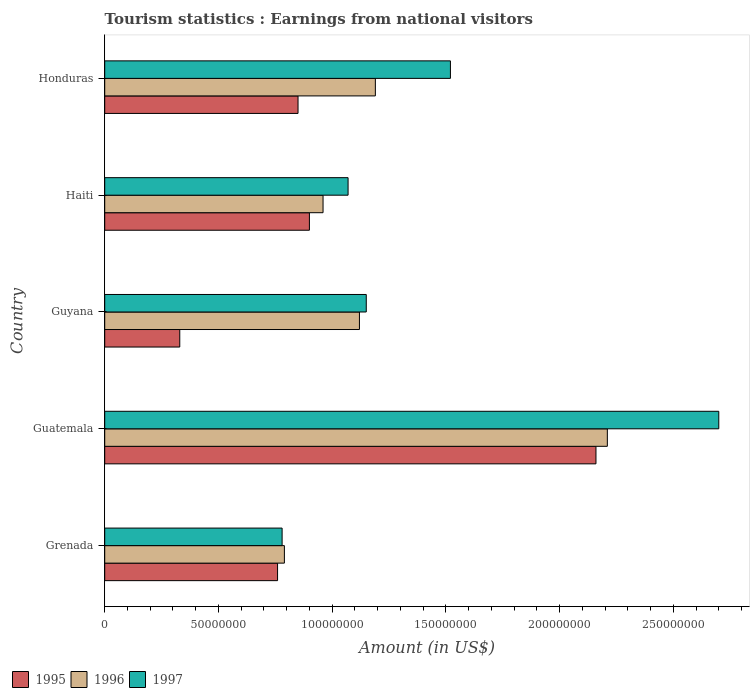How many different coloured bars are there?
Offer a very short reply. 3. How many groups of bars are there?
Provide a succinct answer. 5. Are the number of bars on each tick of the Y-axis equal?
Offer a very short reply. Yes. What is the label of the 4th group of bars from the top?
Keep it short and to the point. Guatemala. In how many cases, is the number of bars for a given country not equal to the number of legend labels?
Your answer should be very brief. 0. What is the earnings from national visitors in 1996 in Guatemala?
Give a very brief answer. 2.21e+08. Across all countries, what is the maximum earnings from national visitors in 1997?
Provide a succinct answer. 2.70e+08. Across all countries, what is the minimum earnings from national visitors in 1996?
Your answer should be compact. 7.90e+07. In which country was the earnings from national visitors in 1996 maximum?
Offer a terse response. Guatemala. In which country was the earnings from national visitors in 1997 minimum?
Your response must be concise. Grenada. What is the total earnings from national visitors in 1997 in the graph?
Keep it short and to the point. 7.22e+08. What is the difference between the earnings from national visitors in 1996 in Grenada and that in Guyana?
Keep it short and to the point. -3.30e+07. What is the difference between the earnings from national visitors in 1995 in Guyana and the earnings from national visitors in 1997 in Honduras?
Offer a terse response. -1.19e+08. What is the difference between the earnings from national visitors in 1995 and earnings from national visitors in 1997 in Honduras?
Provide a short and direct response. -6.70e+07. In how many countries, is the earnings from national visitors in 1995 greater than 180000000 US$?
Your answer should be very brief. 1. What is the ratio of the earnings from national visitors in 1996 in Guyana to that in Honduras?
Your response must be concise. 0.94. Is the earnings from national visitors in 1997 in Grenada less than that in Guatemala?
Give a very brief answer. Yes. What is the difference between the highest and the second highest earnings from national visitors in 1997?
Ensure brevity in your answer.  1.18e+08. What is the difference between the highest and the lowest earnings from national visitors in 1997?
Provide a short and direct response. 1.92e+08. In how many countries, is the earnings from national visitors in 1996 greater than the average earnings from national visitors in 1996 taken over all countries?
Keep it short and to the point. 1. Is the sum of the earnings from national visitors in 1997 in Grenada and Haiti greater than the maximum earnings from national visitors in 1996 across all countries?
Provide a short and direct response. No. What does the 3rd bar from the top in Honduras represents?
Offer a terse response. 1995. Is it the case that in every country, the sum of the earnings from national visitors in 1996 and earnings from national visitors in 1997 is greater than the earnings from national visitors in 1995?
Give a very brief answer. Yes. Are all the bars in the graph horizontal?
Provide a succinct answer. Yes. Are the values on the major ticks of X-axis written in scientific E-notation?
Keep it short and to the point. No. How are the legend labels stacked?
Your response must be concise. Horizontal. What is the title of the graph?
Offer a terse response. Tourism statistics : Earnings from national visitors. Does "1984" appear as one of the legend labels in the graph?
Provide a succinct answer. No. What is the label or title of the Y-axis?
Ensure brevity in your answer.  Country. What is the Amount (in US$) of 1995 in Grenada?
Keep it short and to the point. 7.60e+07. What is the Amount (in US$) in 1996 in Grenada?
Give a very brief answer. 7.90e+07. What is the Amount (in US$) in 1997 in Grenada?
Your answer should be compact. 7.80e+07. What is the Amount (in US$) in 1995 in Guatemala?
Keep it short and to the point. 2.16e+08. What is the Amount (in US$) of 1996 in Guatemala?
Your answer should be very brief. 2.21e+08. What is the Amount (in US$) of 1997 in Guatemala?
Provide a short and direct response. 2.70e+08. What is the Amount (in US$) of 1995 in Guyana?
Your answer should be very brief. 3.30e+07. What is the Amount (in US$) in 1996 in Guyana?
Offer a terse response. 1.12e+08. What is the Amount (in US$) of 1997 in Guyana?
Keep it short and to the point. 1.15e+08. What is the Amount (in US$) of 1995 in Haiti?
Give a very brief answer. 9.00e+07. What is the Amount (in US$) in 1996 in Haiti?
Provide a succinct answer. 9.60e+07. What is the Amount (in US$) in 1997 in Haiti?
Provide a succinct answer. 1.07e+08. What is the Amount (in US$) in 1995 in Honduras?
Your response must be concise. 8.50e+07. What is the Amount (in US$) in 1996 in Honduras?
Give a very brief answer. 1.19e+08. What is the Amount (in US$) in 1997 in Honduras?
Give a very brief answer. 1.52e+08. Across all countries, what is the maximum Amount (in US$) of 1995?
Your answer should be very brief. 2.16e+08. Across all countries, what is the maximum Amount (in US$) of 1996?
Ensure brevity in your answer.  2.21e+08. Across all countries, what is the maximum Amount (in US$) of 1997?
Your answer should be very brief. 2.70e+08. Across all countries, what is the minimum Amount (in US$) in 1995?
Your answer should be very brief. 3.30e+07. Across all countries, what is the minimum Amount (in US$) of 1996?
Provide a short and direct response. 7.90e+07. Across all countries, what is the minimum Amount (in US$) of 1997?
Keep it short and to the point. 7.80e+07. What is the total Amount (in US$) of 1996 in the graph?
Ensure brevity in your answer.  6.27e+08. What is the total Amount (in US$) of 1997 in the graph?
Make the answer very short. 7.22e+08. What is the difference between the Amount (in US$) of 1995 in Grenada and that in Guatemala?
Offer a terse response. -1.40e+08. What is the difference between the Amount (in US$) in 1996 in Grenada and that in Guatemala?
Keep it short and to the point. -1.42e+08. What is the difference between the Amount (in US$) of 1997 in Grenada and that in Guatemala?
Offer a terse response. -1.92e+08. What is the difference between the Amount (in US$) in 1995 in Grenada and that in Guyana?
Your response must be concise. 4.30e+07. What is the difference between the Amount (in US$) of 1996 in Grenada and that in Guyana?
Provide a short and direct response. -3.30e+07. What is the difference between the Amount (in US$) of 1997 in Grenada and that in Guyana?
Your answer should be compact. -3.70e+07. What is the difference between the Amount (in US$) of 1995 in Grenada and that in Haiti?
Provide a short and direct response. -1.40e+07. What is the difference between the Amount (in US$) in 1996 in Grenada and that in Haiti?
Your answer should be compact. -1.70e+07. What is the difference between the Amount (in US$) of 1997 in Grenada and that in Haiti?
Offer a terse response. -2.90e+07. What is the difference between the Amount (in US$) of 1995 in Grenada and that in Honduras?
Your response must be concise. -9.00e+06. What is the difference between the Amount (in US$) in 1996 in Grenada and that in Honduras?
Provide a succinct answer. -4.00e+07. What is the difference between the Amount (in US$) in 1997 in Grenada and that in Honduras?
Ensure brevity in your answer.  -7.40e+07. What is the difference between the Amount (in US$) of 1995 in Guatemala and that in Guyana?
Provide a succinct answer. 1.83e+08. What is the difference between the Amount (in US$) in 1996 in Guatemala and that in Guyana?
Make the answer very short. 1.09e+08. What is the difference between the Amount (in US$) of 1997 in Guatemala and that in Guyana?
Keep it short and to the point. 1.55e+08. What is the difference between the Amount (in US$) in 1995 in Guatemala and that in Haiti?
Offer a terse response. 1.26e+08. What is the difference between the Amount (in US$) of 1996 in Guatemala and that in Haiti?
Ensure brevity in your answer.  1.25e+08. What is the difference between the Amount (in US$) in 1997 in Guatemala and that in Haiti?
Keep it short and to the point. 1.63e+08. What is the difference between the Amount (in US$) of 1995 in Guatemala and that in Honduras?
Your answer should be very brief. 1.31e+08. What is the difference between the Amount (in US$) of 1996 in Guatemala and that in Honduras?
Make the answer very short. 1.02e+08. What is the difference between the Amount (in US$) of 1997 in Guatemala and that in Honduras?
Keep it short and to the point. 1.18e+08. What is the difference between the Amount (in US$) of 1995 in Guyana and that in Haiti?
Make the answer very short. -5.70e+07. What is the difference between the Amount (in US$) in 1996 in Guyana and that in Haiti?
Your response must be concise. 1.60e+07. What is the difference between the Amount (in US$) of 1995 in Guyana and that in Honduras?
Offer a terse response. -5.20e+07. What is the difference between the Amount (in US$) in 1996 in Guyana and that in Honduras?
Give a very brief answer. -7.00e+06. What is the difference between the Amount (in US$) of 1997 in Guyana and that in Honduras?
Your answer should be compact. -3.70e+07. What is the difference between the Amount (in US$) of 1995 in Haiti and that in Honduras?
Keep it short and to the point. 5.00e+06. What is the difference between the Amount (in US$) in 1996 in Haiti and that in Honduras?
Offer a terse response. -2.30e+07. What is the difference between the Amount (in US$) of 1997 in Haiti and that in Honduras?
Ensure brevity in your answer.  -4.50e+07. What is the difference between the Amount (in US$) of 1995 in Grenada and the Amount (in US$) of 1996 in Guatemala?
Make the answer very short. -1.45e+08. What is the difference between the Amount (in US$) in 1995 in Grenada and the Amount (in US$) in 1997 in Guatemala?
Offer a terse response. -1.94e+08. What is the difference between the Amount (in US$) of 1996 in Grenada and the Amount (in US$) of 1997 in Guatemala?
Your answer should be compact. -1.91e+08. What is the difference between the Amount (in US$) of 1995 in Grenada and the Amount (in US$) of 1996 in Guyana?
Offer a terse response. -3.60e+07. What is the difference between the Amount (in US$) in 1995 in Grenada and the Amount (in US$) in 1997 in Guyana?
Keep it short and to the point. -3.90e+07. What is the difference between the Amount (in US$) of 1996 in Grenada and the Amount (in US$) of 1997 in Guyana?
Offer a very short reply. -3.60e+07. What is the difference between the Amount (in US$) of 1995 in Grenada and the Amount (in US$) of 1996 in Haiti?
Offer a terse response. -2.00e+07. What is the difference between the Amount (in US$) in 1995 in Grenada and the Amount (in US$) in 1997 in Haiti?
Ensure brevity in your answer.  -3.10e+07. What is the difference between the Amount (in US$) of 1996 in Grenada and the Amount (in US$) of 1997 in Haiti?
Offer a terse response. -2.80e+07. What is the difference between the Amount (in US$) of 1995 in Grenada and the Amount (in US$) of 1996 in Honduras?
Offer a very short reply. -4.30e+07. What is the difference between the Amount (in US$) of 1995 in Grenada and the Amount (in US$) of 1997 in Honduras?
Make the answer very short. -7.60e+07. What is the difference between the Amount (in US$) of 1996 in Grenada and the Amount (in US$) of 1997 in Honduras?
Offer a terse response. -7.30e+07. What is the difference between the Amount (in US$) of 1995 in Guatemala and the Amount (in US$) of 1996 in Guyana?
Provide a succinct answer. 1.04e+08. What is the difference between the Amount (in US$) of 1995 in Guatemala and the Amount (in US$) of 1997 in Guyana?
Provide a short and direct response. 1.01e+08. What is the difference between the Amount (in US$) of 1996 in Guatemala and the Amount (in US$) of 1997 in Guyana?
Your answer should be very brief. 1.06e+08. What is the difference between the Amount (in US$) of 1995 in Guatemala and the Amount (in US$) of 1996 in Haiti?
Keep it short and to the point. 1.20e+08. What is the difference between the Amount (in US$) in 1995 in Guatemala and the Amount (in US$) in 1997 in Haiti?
Ensure brevity in your answer.  1.09e+08. What is the difference between the Amount (in US$) of 1996 in Guatemala and the Amount (in US$) of 1997 in Haiti?
Your answer should be compact. 1.14e+08. What is the difference between the Amount (in US$) in 1995 in Guatemala and the Amount (in US$) in 1996 in Honduras?
Provide a short and direct response. 9.70e+07. What is the difference between the Amount (in US$) of 1995 in Guatemala and the Amount (in US$) of 1997 in Honduras?
Your answer should be very brief. 6.40e+07. What is the difference between the Amount (in US$) in 1996 in Guatemala and the Amount (in US$) in 1997 in Honduras?
Provide a succinct answer. 6.90e+07. What is the difference between the Amount (in US$) in 1995 in Guyana and the Amount (in US$) in 1996 in Haiti?
Provide a short and direct response. -6.30e+07. What is the difference between the Amount (in US$) of 1995 in Guyana and the Amount (in US$) of 1997 in Haiti?
Ensure brevity in your answer.  -7.40e+07. What is the difference between the Amount (in US$) in 1995 in Guyana and the Amount (in US$) in 1996 in Honduras?
Provide a short and direct response. -8.60e+07. What is the difference between the Amount (in US$) in 1995 in Guyana and the Amount (in US$) in 1997 in Honduras?
Provide a short and direct response. -1.19e+08. What is the difference between the Amount (in US$) in 1996 in Guyana and the Amount (in US$) in 1997 in Honduras?
Ensure brevity in your answer.  -4.00e+07. What is the difference between the Amount (in US$) of 1995 in Haiti and the Amount (in US$) of 1996 in Honduras?
Offer a very short reply. -2.90e+07. What is the difference between the Amount (in US$) in 1995 in Haiti and the Amount (in US$) in 1997 in Honduras?
Offer a very short reply. -6.20e+07. What is the difference between the Amount (in US$) of 1996 in Haiti and the Amount (in US$) of 1997 in Honduras?
Provide a succinct answer. -5.60e+07. What is the average Amount (in US$) of 1996 per country?
Your answer should be compact. 1.25e+08. What is the average Amount (in US$) in 1997 per country?
Your response must be concise. 1.44e+08. What is the difference between the Amount (in US$) of 1995 and Amount (in US$) of 1996 in Grenada?
Make the answer very short. -3.00e+06. What is the difference between the Amount (in US$) of 1995 and Amount (in US$) of 1996 in Guatemala?
Make the answer very short. -5.00e+06. What is the difference between the Amount (in US$) of 1995 and Amount (in US$) of 1997 in Guatemala?
Provide a short and direct response. -5.40e+07. What is the difference between the Amount (in US$) in 1996 and Amount (in US$) in 1997 in Guatemala?
Give a very brief answer. -4.90e+07. What is the difference between the Amount (in US$) of 1995 and Amount (in US$) of 1996 in Guyana?
Ensure brevity in your answer.  -7.90e+07. What is the difference between the Amount (in US$) in 1995 and Amount (in US$) in 1997 in Guyana?
Provide a short and direct response. -8.20e+07. What is the difference between the Amount (in US$) of 1996 and Amount (in US$) of 1997 in Guyana?
Provide a short and direct response. -3.00e+06. What is the difference between the Amount (in US$) in 1995 and Amount (in US$) in 1996 in Haiti?
Ensure brevity in your answer.  -6.00e+06. What is the difference between the Amount (in US$) in 1995 and Amount (in US$) in 1997 in Haiti?
Your answer should be very brief. -1.70e+07. What is the difference between the Amount (in US$) in 1996 and Amount (in US$) in 1997 in Haiti?
Make the answer very short. -1.10e+07. What is the difference between the Amount (in US$) of 1995 and Amount (in US$) of 1996 in Honduras?
Offer a terse response. -3.40e+07. What is the difference between the Amount (in US$) of 1995 and Amount (in US$) of 1997 in Honduras?
Give a very brief answer. -6.70e+07. What is the difference between the Amount (in US$) of 1996 and Amount (in US$) of 1997 in Honduras?
Keep it short and to the point. -3.30e+07. What is the ratio of the Amount (in US$) in 1995 in Grenada to that in Guatemala?
Ensure brevity in your answer.  0.35. What is the ratio of the Amount (in US$) in 1996 in Grenada to that in Guatemala?
Keep it short and to the point. 0.36. What is the ratio of the Amount (in US$) of 1997 in Grenada to that in Guatemala?
Give a very brief answer. 0.29. What is the ratio of the Amount (in US$) in 1995 in Grenada to that in Guyana?
Your answer should be compact. 2.3. What is the ratio of the Amount (in US$) in 1996 in Grenada to that in Guyana?
Give a very brief answer. 0.71. What is the ratio of the Amount (in US$) of 1997 in Grenada to that in Guyana?
Ensure brevity in your answer.  0.68. What is the ratio of the Amount (in US$) of 1995 in Grenada to that in Haiti?
Your answer should be compact. 0.84. What is the ratio of the Amount (in US$) in 1996 in Grenada to that in Haiti?
Offer a terse response. 0.82. What is the ratio of the Amount (in US$) in 1997 in Grenada to that in Haiti?
Offer a very short reply. 0.73. What is the ratio of the Amount (in US$) of 1995 in Grenada to that in Honduras?
Make the answer very short. 0.89. What is the ratio of the Amount (in US$) of 1996 in Grenada to that in Honduras?
Your answer should be compact. 0.66. What is the ratio of the Amount (in US$) in 1997 in Grenada to that in Honduras?
Offer a terse response. 0.51. What is the ratio of the Amount (in US$) in 1995 in Guatemala to that in Guyana?
Provide a succinct answer. 6.55. What is the ratio of the Amount (in US$) of 1996 in Guatemala to that in Guyana?
Offer a terse response. 1.97. What is the ratio of the Amount (in US$) in 1997 in Guatemala to that in Guyana?
Your answer should be very brief. 2.35. What is the ratio of the Amount (in US$) in 1996 in Guatemala to that in Haiti?
Offer a very short reply. 2.3. What is the ratio of the Amount (in US$) in 1997 in Guatemala to that in Haiti?
Your response must be concise. 2.52. What is the ratio of the Amount (in US$) of 1995 in Guatemala to that in Honduras?
Offer a terse response. 2.54. What is the ratio of the Amount (in US$) of 1996 in Guatemala to that in Honduras?
Your answer should be compact. 1.86. What is the ratio of the Amount (in US$) of 1997 in Guatemala to that in Honduras?
Your response must be concise. 1.78. What is the ratio of the Amount (in US$) in 1995 in Guyana to that in Haiti?
Keep it short and to the point. 0.37. What is the ratio of the Amount (in US$) of 1997 in Guyana to that in Haiti?
Give a very brief answer. 1.07. What is the ratio of the Amount (in US$) of 1995 in Guyana to that in Honduras?
Give a very brief answer. 0.39. What is the ratio of the Amount (in US$) of 1996 in Guyana to that in Honduras?
Your answer should be compact. 0.94. What is the ratio of the Amount (in US$) in 1997 in Guyana to that in Honduras?
Offer a terse response. 0.76. What is the ratio of the Amount (in US$) in 1995 in Haiti to that in Honduras?
Your answer should be compact. 1.06. What is the ratio of the Amount (in US$) in 1996 in Haiti to that in Honduras?
Offer a very short reply. 0.81. What is the ratio of the Amount (in US$) of 1997 in Haiti to that in Honduras?
Offer a terse response. 0.7. What is the difference between the highest and the second highest Amount (in US$) of 1995?
Make the answer very short. 1.26e+08. What is the difference between the highest and the second highest Amount (in US$) in 1996?
Give a very brief answer. 1.02e+08. What is the difference between the highest and the second highest Amount (in US$) of 1997?
Your answer should be very brief. 1.18e+08. What is the difference between the highest and the lowest Amount (in US$) in 1995?
Provide a short and direct response. 1.83e+08. What is the difference between the highest and the lowest Amount (in US$) of 1996?
Make the answer very short. 1.42e+08. What is the difference between the highest and the lowest Amount (in US$) in 1997?
Ensure brevity in your answer.  1.92e+08. 